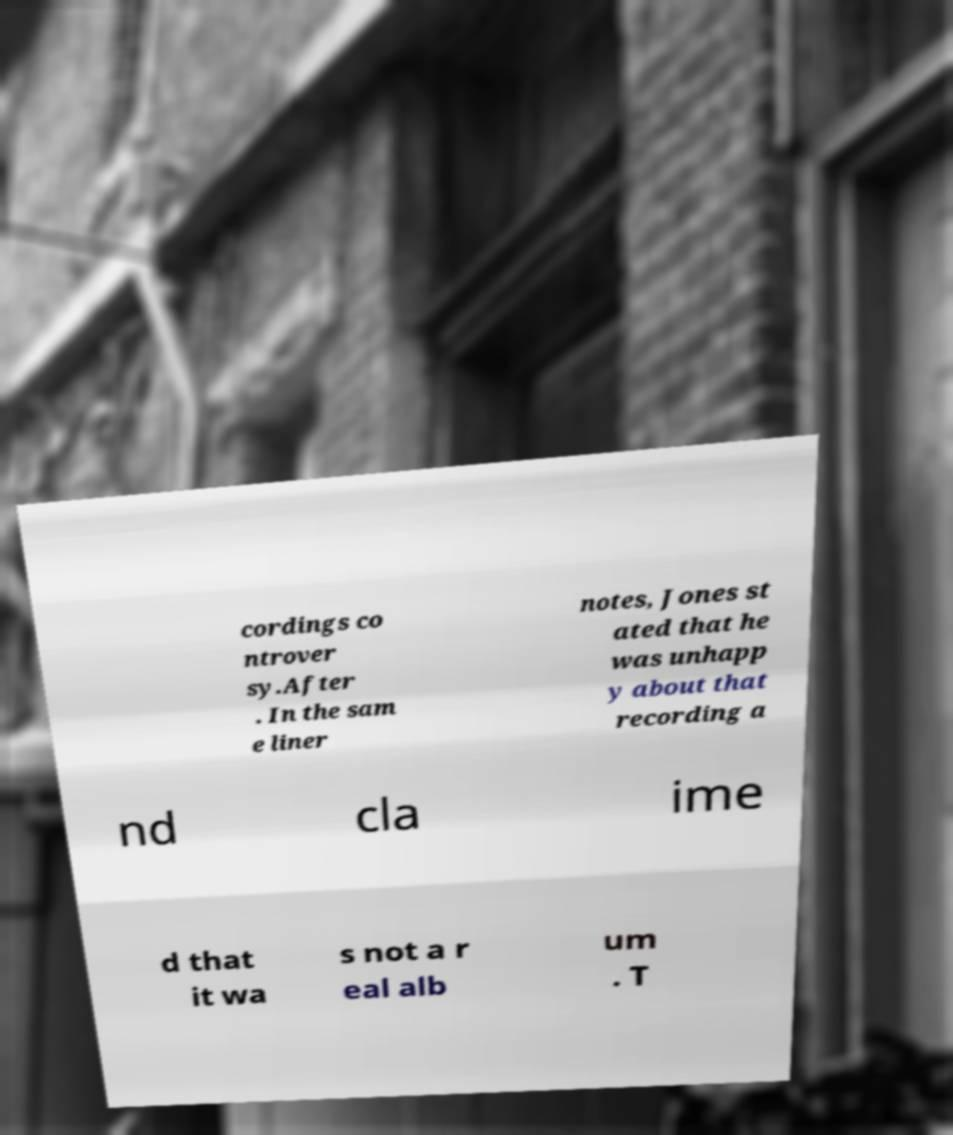Can you accurately transcribe the text from the provided image for me? cordings co ntrover sy.After . In the sam e liner notes, Jones st ated that he was unhapp y about that recording a nd cla ime d that it wa s not a r eal alb um . T 